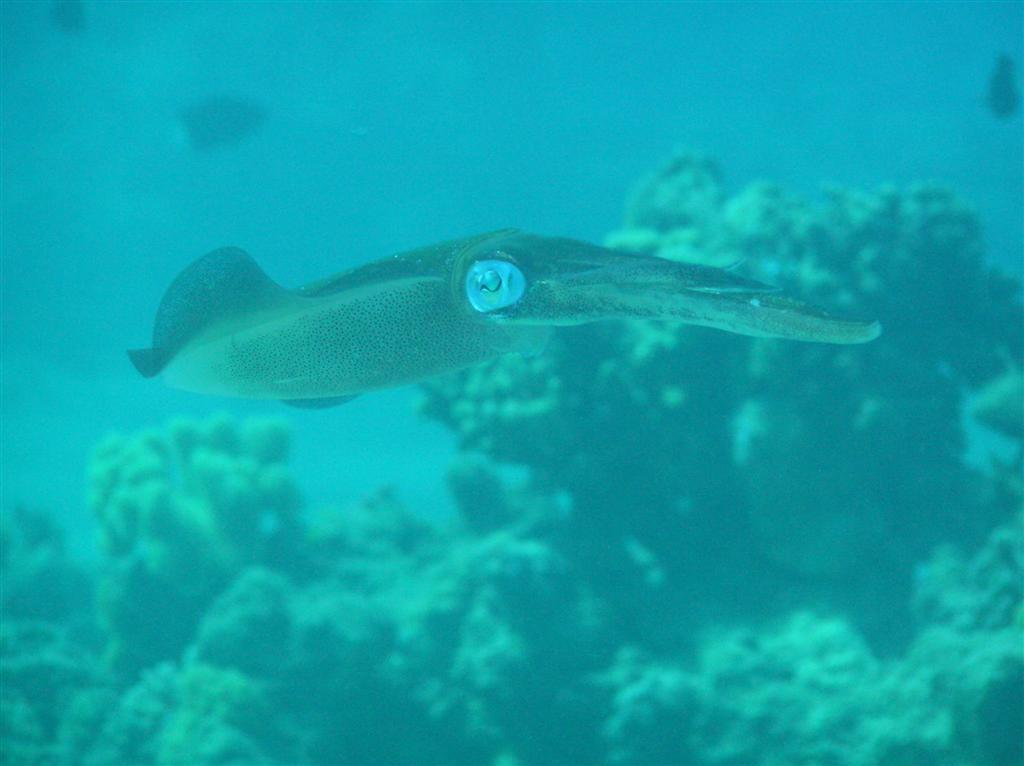What type of environment is shown in the image? The image depicts an underwater environment. What type of animal can be seen in the image? There is a fish in the image. What objects can be seen in the background of the image? There are objects in the background that resemble rocks. What type of cheese is being used as a volleyball in the image? There is no cheese or volleyball present in the image; it depicts an underwater environment with a fish and rocks. 